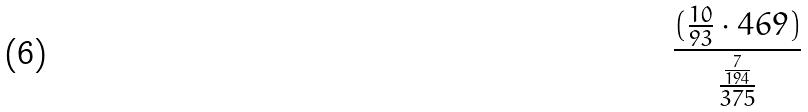Convert formula to latex. <formula><loc_0><loc_0><loc_500><loc_500>\frac { ( \frac { 1 0 } { 9 3 } \cdot 4 6 9 ) } { \frac { \frac { 7 } { 1 9 4 } } { 3 7 5 } }</formula> 